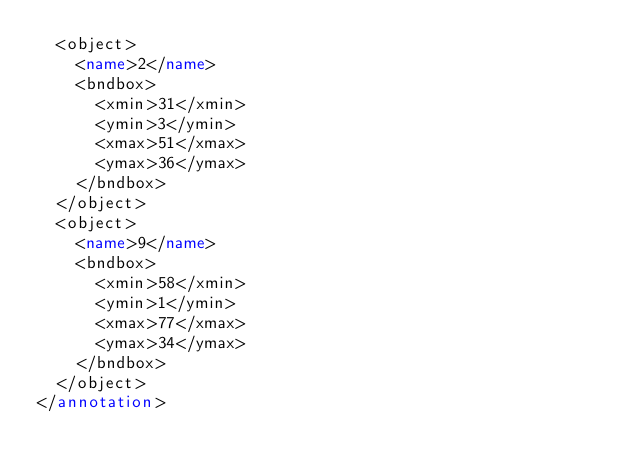Convert code to text. <code><loc_0><loc_0><loc_500><loc_500><_XML_>  <object>
    <name>2</name>
    <bndbox>
      <xmin>31</xmin>
      <ymin>3</ymin>
      <xmax>51</xmax>
      <ymax>36</ymax>
    </bndbox>
  </object>
  <object>
    <name>9</name>
    <bndbox>
      <xmin>58</xmin>
      <ymin>1</ymin>
      <xmax>77</xmax>
      <ymax>34</ymax>
    </bndbox>
  </object>
</annotation>
</code> 